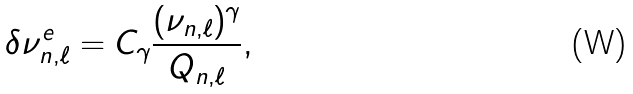<formula> <loc_0><loc_0><loc_500><loc_500>\delta \nu ^ { e } _ { n , \ell } = C _ { \gamma } \frac { ( \nu _ { n , \ell } ) ^ { \gamma } } { Q _ { n , \ell } } ,</formula> 